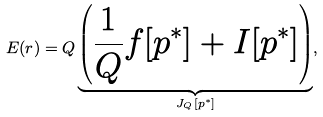Convert formula to latex. <formula><loc_0><loc_0><loc_500><loc_500>E ( r ) = Q \underbrace { \left ( \frac { 1 } { Q } f [ p ^ { * } ] + I [ p ^ { * } ] \right ) } _ { J _ { Q } [ p ^ { * } ] } ,</formula> 